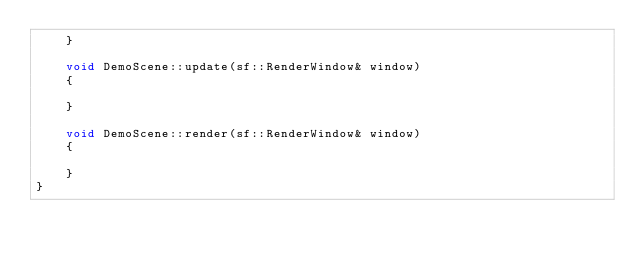Convert code to text. <code><loc_0><loc_0><loc_500><loc_500><_C++_>    }
    
    void DemoScene::update(sf::RenderWindow& window)
    {
        
    }
    
    void DemoScene::render(sf::RenderWindow& window)
    {
        
    }
}</code> 